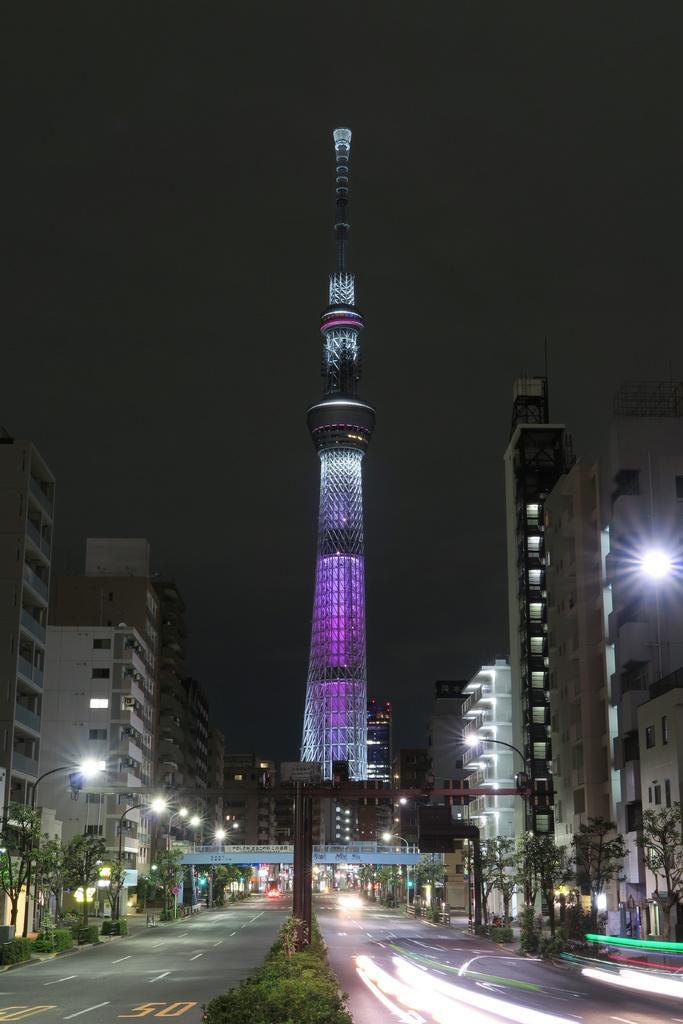Describe this image in one or two sentences. In this image we can see the buildings, lights, there are a few plants and trees, street lights, there is a road and vehicles, we can see the sky. 